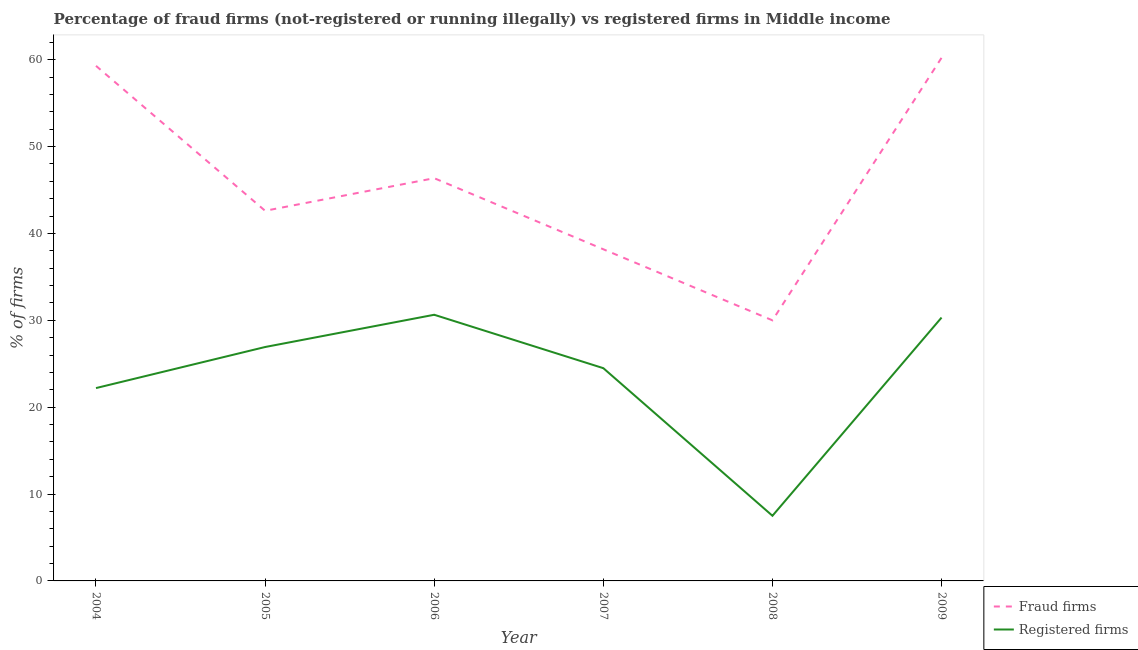Is the number of lines equal to the number of legend labels?
Offer a very short reply. Yes. What is the percentage of fraud firms in 2005?
Your response must be concise. 42.61. Across all years, what is the maximum percentage of fraud firms?
Provide a succinct answer. 60.23. Across all years, what is the minimum percentage of fraud firms?
Give a very brief answer. 30. In which year was the percentage of fraud firms minimum?
Provide a succinct answer. 2008. What is the total percentage of fraud firms in the graph?
Make the answer very short. 276.68. What is the difference between the percentage of registered firms in 2005 and that in 2009?
Keep it short and to the point. -3.39. What is the difference between the percentage of fraud firms in 2004 and the percentage of registered firms in 2008?
Provide a short and direct response. 51.8. What is the average percentage of registered firms per year?
Provide a succinct answer. 23.68. In the year 2004, what is the difference between the percentage of fraud firms and percentage of registered firms?
Offer a terse response. 37.1. In how many years, is the percentage of registered firms greater than 2 %?
Ensure brevity in your answer.  6. What is the ratio of the percentage of registered firms in 2005 to that in 2007?
Ensure brevity in your answer.  1.1. What is the difference between the highest and the second highest percentage of fraud firms?
Keep it short and to the point. 0.93. What is the difference between the highest and the lowest percentage of fraud firms?
Give a very brief answer. 30.23. Is the sum of the percentage of registered firms in 2005 and 2008 greater than the maximum percentage of fraud firms across all years?
Offer a very short reply. No. Is the percentage of fraud firms strictly greater than the percentage of registered firms over the years?
Offer a terse response. Yes. Is the percentage of fraud firms strictly less than the percentage of registered firms over the years?
Offer a very short reply. No. How many lines are there?
Provide a succinct answer. 2. How many years are there in the graph?
Ensure brevity in your answer.  6. What is the difference between two consecutive major ticks on the Y-axis?
Keep it short and to the point. 10. Does the graph contain any zero values?
Provide a succinct answer. No. Where does the legend appear in the graph?
Provide a succinct answer. Bottom right. How many legend labels are there?
Offer a terse response. 2. How are the legend labels stacked?
Your response must be concise. Vertical. What is the title of the graph?
Offer a terse response. Percentage of fraud firms (not-registered or running illegally) vs registered firms in Middle income. Does "Automatic Teller Machines" appear as one of the legend labels in the graph?
Keep it short and to the point. No. What is the label or title of the Y-axis?
Make the answer very short. % of firms. What is the % of firms of Fraud firms in 2004?
Your response must be concise. 59.3. What is the % of firms in Registered firms in 2004?
Ensure brevity in your answer.  22.2. What is the % of firms of Fraud firms in 2005?
Your answer should be very brief. 42.61. What is the % of firms in Registered firms in 2005?
Your response must be concise. 26.93. What is the % of firms of Fraud firms in 2006?
Your answer should be very brief. 46.36. What is the % of firms in Registered firms in 2006?
Provide a succinct answer. 30.64. What is the % of firms in Fraud firms in 2007?
Your answer should be compact. 38.18. What is the % of firms in Registered firms in 2007?
Offer a very short reply. 24.49. What is the % of firms in Fraud firms in 2008?
Make the answer very short. 30. What is the % of firms of Fraud firms in 2009?
Provide a succinct answer. 60.23. What is the % of firms in Registered firms in 2009?
Make the answer very short. 30.32. Across all years, what is the maximum % of firms in Fraud firms?
Provide a short and direct response. 60.23. Across all years, what is the maximum % of firms in Registered firms?
Provide a succinct answer. 30.64. What is the total % of firms in Fraud firms in the graph?
Your response must be concise. 276.68. What is the total % of firms of Registered firms in the graph?
Your answer should be very brief. 142.08. What is the difference between the % of firms in Fraud firms in 2004 and that in 2005?
Offer a terse response. 16.69. What is the difference between the % of firms in Registered firms in 2004 and that in 2005?
Your response must be concise. -4.73. What is the difference between the % of firms of Fraud firms in 2004 and that in 2006?
Your answer should be compact. 12.93. What is the difference between the % of firms of Registered firms in 2004 and that in 2006?
Provide a short and direct response. -8.44. What is the difference between the % of firms in Fraud firms in 2004 and that in 2007?
Give a very brief answer. 21.12. What is the difference between the % of firms of Registered firms in 2004 and that in 2007?
Keep it short and to the point. -2.29. What is the difference between the % of firms of Fraud firms in 2004 and that in 2008?
Offer a very short reply. 29.3. What is the difference between the % of firms in Registered firms in 2004 and that in 2008?
Your response must be concise. 14.7. What is the difference between the % of firms of Fraud firms in 2004 and that in 2009?
Give a very brief answer. -0.93. What is the difference between the % of firms in Registered firms in 2004 and that in 2009?
Ensure brevity in your answer.  -8.12. What is the difference between the % of firms of Fraud firms in 2005 and that in 2006?
Offer a terse response. -3.75. What is the difference between the % of firms in Registered firms in 2005 and that in 2006?
Make the answer very short. -3.71. What is the difference between the % of firms in Fraud firms in 2005 and that in 2007?
Make the answer very short. 4.43. What is the difference between the % of firms of Registered firms in 2005 and that in 2007?
Make the answer very short. 2.43. What is the difference between the % of firms of Fraud firms in 2005 and that in 2008?
Your answer should be very brief. 12.61. What is the difference between the % of firms in Registered firms in 2005 and that in 2008?
Your answer should be very brief. 19.43. What is the difference between the % of firms in Fraud firms in 2005 and that in 2009?
Provide a short and direct response. -17.62. What is the difference between the % of firms of Registered firms in 2005 and that in 2009?
Keep it short and to the point. -3.39. What is the difference between the % of firms in Fraud firms in 2006 and that in 2007?
Keep it short and to the point. 8.18. What is the difference between the % of firms in Registered firms in 2006 and that in 2007?
Make the answer very short. 6.15. What is the difference between the % of firms in Fraud firms in 2006 and that in 2008?
Your answer should be compact. 16.36. What is the difference between the % of firms of Registered firms in 2006 and that in 2008?
Provide a short and direct response. 23.14. What is the difference between the % of firms of Fraud firms in 2006 and that in 2009?
Your answer should be compact. -13.86. What is the difference between the % of firms in Registered firms in 2006 and that in 2009?
Keep it short and to the point. 0.32. What is the difference between the % of firms of Fraud firms in 2007 and that in 2008?
Give a very brief answer. 8.18. What is the difference between the % of firms in Registered firms in 2007 and that in 2008?
Your answer should be very brief. 16.99. What is the difference between the % of firms of Fraud firms in 2007 and that in 2009?
Your answer should be very brief. -22.05. What is the difference between the % of firms in Registered firms in 2007 and that in 2009?
Offer a very short reply. -5.83. What is the difference between the % of firms of Fraud firms in 2008 and that in 2009?
Make the answer very short. -30.23. What is the difference between the % of firms of Registered firms in 2008 and that in 2009?
Your response must be concise. -22.82. What is the difference between the % of firms of Fraud firms in 2004 and the % of firms of Registered firms in 2005?
Your response must be concise. 32.37. What is the difference between the % of firms in Fraud firms in 2004 and the % of firms in Registered firms in 2006?
Your answer should be very brief. 28.66. What is the difference between the % of firms of Fraud firms in 2004 and the % of firms of Registered firms in 2007?
Keep it short and to the point. 34.8. What is the difference between the % of firms of Fraud firms in 2004 and the % of firms of Registered firms in 2008?
Give a very brief answer. 51.8. What is the difference between the % of firms of Fraud firms in 2004 and the % of firms of Registered firms in 2009?
Ensure brevity in your answer.  28.98. What is the difference between the % of firms of Fraud firms in 2005 and the % of firms of Registered firms in 2006?
Provide a succinct answer. 11.97. What is the difference between the % of firms in Fraud firms in 2005 and the % of firms in Registered firms in 2007?
Ensure brevity in your answer.  18.12. What is the difference between the % of firms in Fraud firms in 2005 and the % of firms in Registered firms in 2008?
Keep it short and to the point. 35.11. What is the difference between the % of firms of Fraud firms in 2005 and the % of firms of Registered firms in 2009?
Give a very brief answer. 12.29. What is the difference between the % of firms of Fraud firms in 2006 and the % of firms of Registered firms in 2007?
Provide a succinct answer. 21.87. What is the difference between the % of firms of Fraud firms in 2006 and the % of firms of Registered firms in 2008?
Provide a short and direct response. 38.86. What is the difference between the % of firms of Fraud firms in 2006 and the % of firms of Registered firms in 2009?
Ensure brevity in your answer.  16.04. What is the difference between the % of firms of Fraud firms in 2007 and the % of firms of Registered firms in 2008?
Your response must be concise. 30.68. What is the difference between the % of firms of Fraud firms in 2007 and the % of firms of Registered firms in 2009?
Your answer should be very brief. 7.86. What is the difference between the % of firms of Fraud firms in 2008 and the % of firms of Registered firms in 2009?
Your answer should be very brief. -0.32. What is the average % of firms in Fraud firms per year?
Offer a very short reply. 46.11. What is the average % of firms of Registered firms per year?
Offer a terse response. 23.68. In the year 2004, what is the difference between the % of firms in Fraud firms and % of firms in Registered firms?
Your response must be concise. 37.1. In the year 2005, what is the difference between the % of firms in Fraud firms and % of firms in Registered firms?
Ensure brevity in your answer.  15.68. In the year 2006, what is the difference between the % of firms of Fraud firms and % of firms of Registered firms?
Your answer should be compact. 15.72. In the year 2007, what is the difference between the % of firms in Fraud firms and % of firms in Registered firms?
Provide a short and direct response. 13.69. In the year 2009, what is the difference between the % of firms in Fraud firms and % of firms in Registered firms?
Your answer should be compact. 29.91. What is the ratio of the % of firms of Fraud firms in 2004 to that in 2005?
Provide a succinct answer. 1.39. What is the ratio of the % of firms of Registered firms in 2004 to that in 2005?
Offer a terse response. 0.82. What is the ratio of the % of firms of Fraud firms in 2004 to that in 2006?
Provide a succinct answer. 1.28. What is the ratio of the % of firms of Registered firms in 2004 to that in 2006?
Offer a terse response. 0.72. What is the ratio of the % of firms in Fraud firms in 2004 to that in 2007?
Your answer should be compact. 1.55. What is the ratio of the % of firms of Registered firms in 2004 to that in 2007?
Provide a succinct answer. 0.91. What is the ratio of the % of firms of Fraud firms in 2004 to that in 2008?
Ensure brevity in your answer.  1.98. What is the ratio of the % of firms of Registered firms in 2004 to that in 2008?
Your response must be concise. 2.96. What is the ratio of the % of firms of Fraud firms in 2004 to that in 2009?
Make the answer very short. 0.98. What is the ratio of the % of firms of Registered firms in 2004 to that in 2009?
Your answer should be compact. 0.73. What is the ratio of the % of firms in Fraud firms in 2005 to that in 2006?
Keep it short and to the point. 0.92. What is the ratio of the % of firms of Registered firms in 2005 to that in 2006?
Make the answer very short. 0.88. What is the ratio of the % of firms in Fraud firms in 2005 to that in 2007?
Provide a succinct answer. 1.12. What is the ratio of the % of firms in Registered firms in 2005 to that in 2007?
Offer a terse response. 1.1. What is the ratio of the % of firms of Fraud firms in 2005 to that in 2008?
Offer a very short reply. 1.42. What is the ratio of the % of firms of Registered firms in 2005 to that in 2008?
Offer a very short reply. 3.59. What is the ratio of the % of firms of Fraud firms in 2005 to that in 2009?
Your response must be concise. 0.71. What is the ratio of the % of firms in Registered firms in 2005 to that in 2009?
Ensure brevity in your answer.  0.89. What is the ratio of the % of firms in Fraud firms in 2006 to that in 2007?
Your answer should be very brief. 1.21. What is the ratio of the % of firms of Registered firms in 2006 to that in 2007?
Your answer should be compact. 1.25. What is the ratio of the % of firms of Fraud firms in 2006 to that in 2008?
Offer a very short reply. 1.55. What is the ratio of the % of firms in Registered firms in 2006 to that in 2008?
Give a very brief answer. 4.09. What is the ratio of the % of firms in Fraud firms in 2006 to that in 2009?
Your answer should be compact. 0.77. What is the ratio of the % of firms of Registered firms in 2006 to that in 2009?
Offer a very short reply. 1.01. What is the ratio of the % of firms in Fraud firms in 2007 to that in 2008?
Provide a short and direct response. 1.27. What is the ratio of the % of firms of Registered firms in 2007 to that in 2008?
Your response must be concise. 3.27. What is the ratio of the % of firms in Fraud firms in 2007 to that in 2009?
Make the answer very short. 0.63. What is the ratio of the % of firms of Registered firms in 2007 to that in 2009?
Make the answer very short. 0.81. What is the ratio of the % of firms in Fraud firms in 2008 to that in 2009?
Your answer should be compact. 0.5. What is the ratio of the % of firms in Registered firms in 2008 to that in 2009?
Your answer should be compact. 0.25. What is the difference between the highest and the second highest % of firms of Fraud firms?
Give a very brief answer. 0.93. What is the difference between the highest and the second highest % of firms in Registered firms?
Your answer should be very brief. 0.32. What is the difference between the highest and the lowest % of firms of Fraud firms?
Provide a succinct answer. 30.23. What is the difference between the highest and the lowest % of firms in Registered firms?
Give a very brief answer. 23.14. 